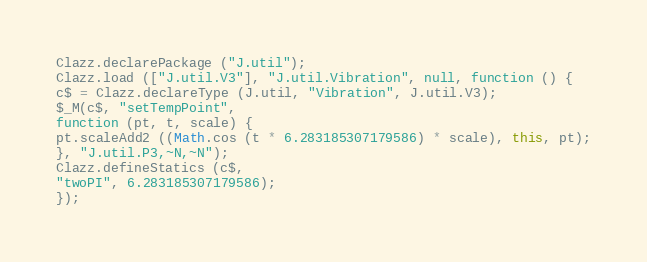Convert code to text. <code><loc_0><loc_0><loc_500><loc_500><_JavaScript_>Clazz.declarePackage ("J.util");
Clazz.load (["J.util.V3"], "J.util.Vibration", null, function () {
c$ = Clazz.declareType (J.util, "Vibration", J.util.V3);
$_M(c$, "setTempPoint", 
function (pt, t, scale) {
pt.scaleAdd2 ((Math.cos (t * 6.283185307179586) * scale), this, pt);
}, "J.util.P3,~N,~N");
Clazz.defineStatics (c$,
"twoPI", 6.283185307179586);
});
</code> 